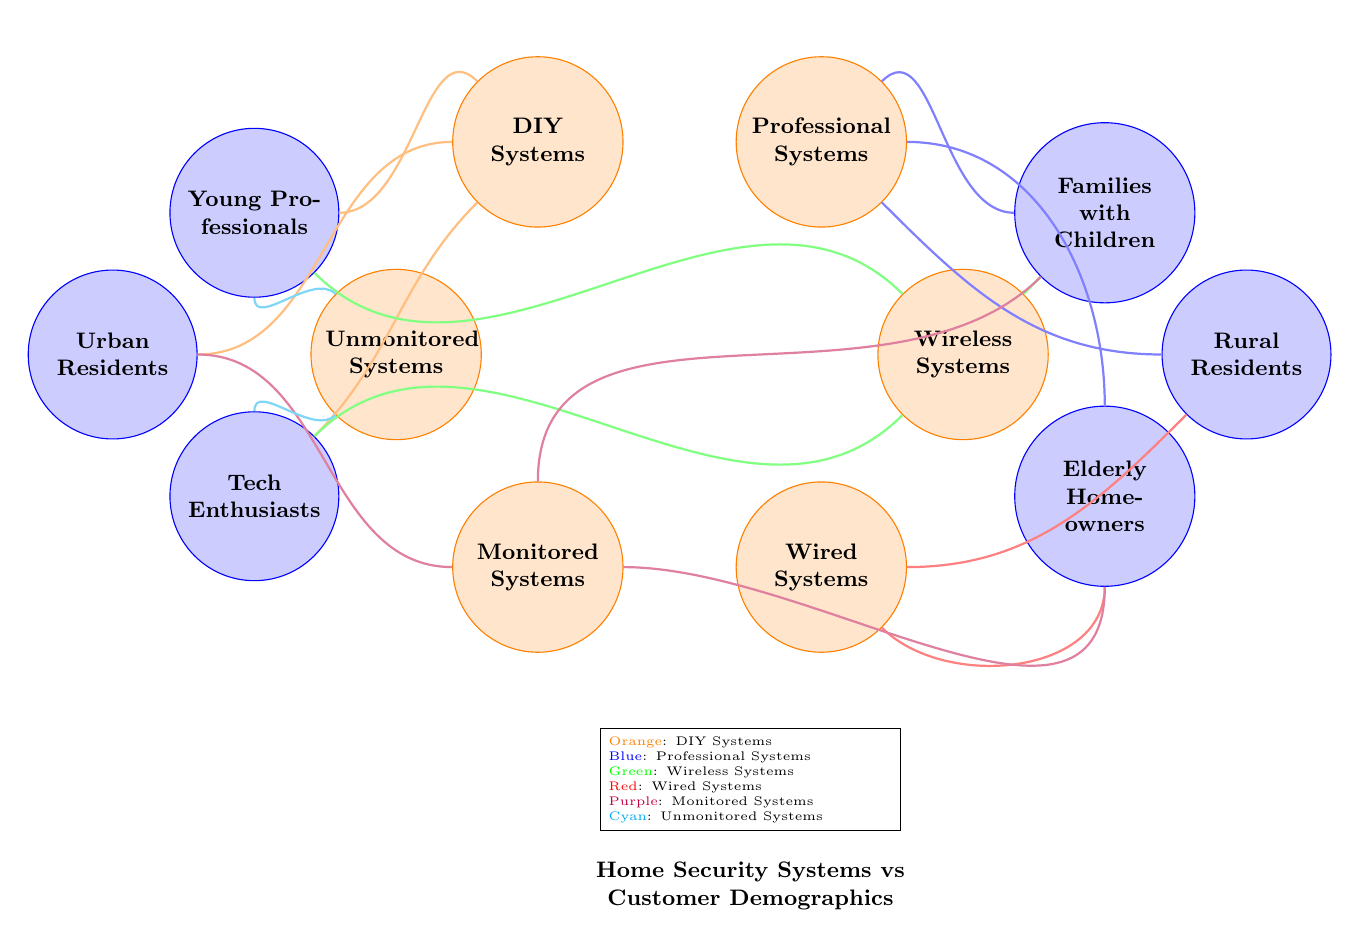What types of home security systems are recommended for Tech Enthusiasts? The diagram shows that Tech Enthusiasts are connected to DIY Systems, Wireless Systems, and Unmonitored Systems.
Answer: DIY Systems, Wireless Systems, Unmonitored Systems Which demographic is associated with Professional Systems? The connection from Professional Systems leads to Families with Children, Elderly Homeowners, and Rural Residents.
Answer: Families with Children, Elderly Homeowners, Rural Residents How many types of home security systems are presented in the diagram? The diagram lists six types of home security systems: DIY Systems, Professional Systems, Wireless Systems, Wired Systems, Monitored Systems, and Unmonitored Systems.
Answer: Six Which type of security system is linked to the most customer demographics? By examining the connections, Monitored Systems is connected to three demographics: Families with Children, Elderly Homeowners, and Urban Residents, indicating it has the most links.
Answer: Monitored Systems Are Wired Systems recommended for Urban Residents? The diagram does not show any connections between Wired Systems and Urban Residents, indicating that it is not recommended for them.
Answer: No What color represents Wireless Systems in the diagram? The visual representation shows that Wireless Systems is depicted in green.
Answer: Green Which demographic is not connected to any unmonitored systems? Reviewing the diagram, we find that Families with Children and Elderly Homeowners are not connected to Unmonitored Systems.
Answer: Families with Children, Elderly Homeowners Which two home security systems are preferred by Young Professionals? According to the connections, Young Professionals are linked to DIY Systems and Unmonitored Systems.
Answer: DIY Systems, Unmonitored Systems How many total edges are there connecting demographics to home security systems? Counting all the connections seen in the diagram gives a total of ten edges connecting various demographics to different systems.
Answer: Ten 